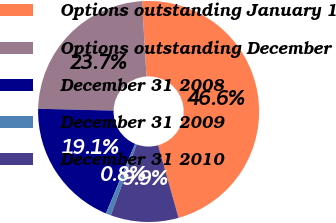<chart> <loc_0><loc_0><loc_500><loc_500><pie_chart><fcel>Options outstanding January 1<fcel>Options outstanding December<fcel>December 31 2008<fcel>December 31 2009<fcel>December 31 2010<nl><fcel>46.58%<fcel>23.66%<fcel>19.08%<fcel>0.76%<fcel>9.92%<nl></chart> 